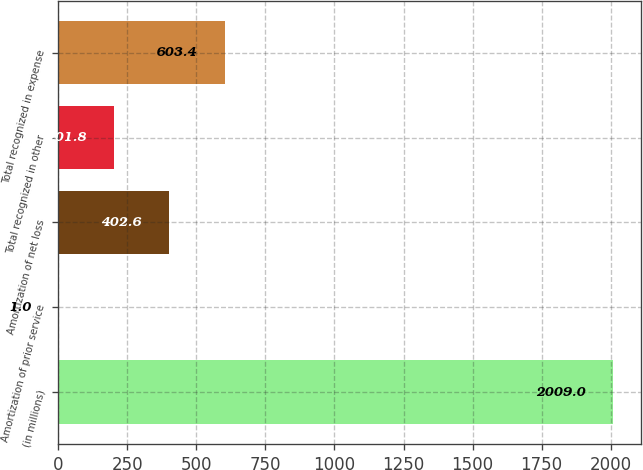Convert chart. <chart><loc_0><loc_0><loc_500><loc_500><bar_chart><fcel>(in millions)<fcel>Amortization of prior service<fcel>Amortization of net loss<fcel>Total recognized in other<fcel>Total recognized in expense<nl><fcel>2009<fcel>1<fcel>402.6<fcel>201.8<fcel>603.4<nl></chart> 